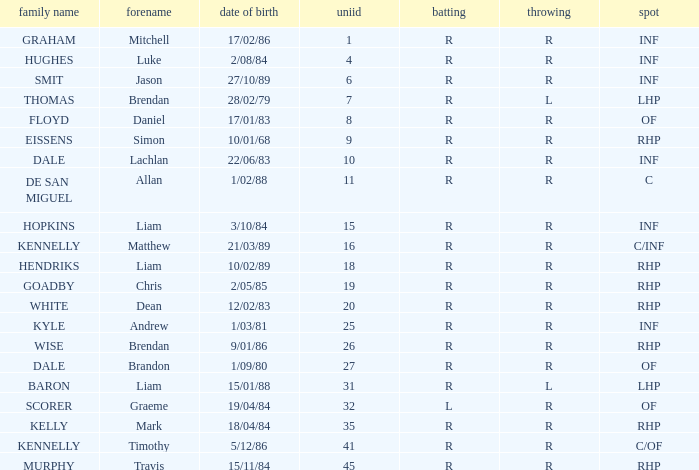Which batter has the last name Graham? R. 